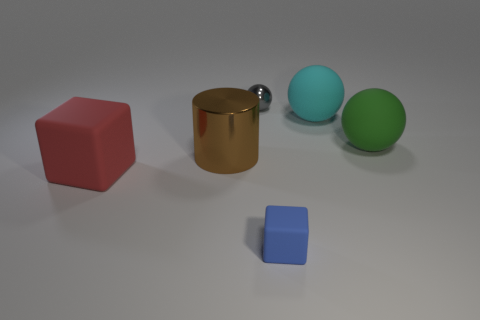Is there a large red rubber object behind the matte block that is on the left side of the small blue matte block?
Your response must be concise. No. Does the rubber block that is behind the small blue rubber cube have the same size as the block that is to the right of the tiny gray metal object?
Give a very brief answer. No. What number of tiny things are gray cubes or brown metallic cylinders?
Provide a succinct answer. 0. There is a cube that is on the left side of the block that is in front of the big cube; what is its material?
Ensure brevity in your answer.  Rubber. Is there another red thing made of the same material as the red thing?
Provide a succinct answer. No. Are the green ball and the large object in front of the large brown cylinder made of the same material?
Provide a succinct answer. Yes. There is a metal thing that is the same size as the cyan rubber ball; what is its color?
Your answer should be compact. Brown. There is a matte cube that is left of the sphere left of the tiny blue thing; what is its size?
Provide a succinct answer. Large. Is the color of the small metal thing the same as the shiny thing that is on the left side of the gray metal ball?
Give a very brief answer. No. Are there fewer tiny things that are in front of the large cyan object than small rubber cylinders?
Make the answer very short. No. 